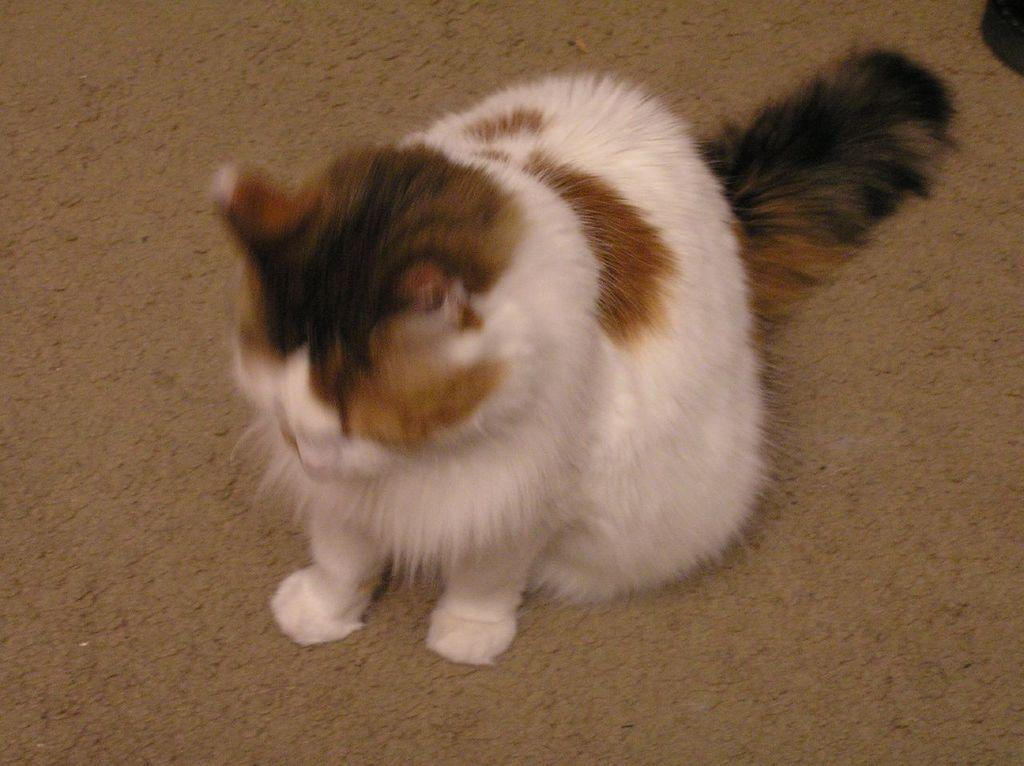What type of animal is in the image? There is a cat in the image. Where is the cat located in the image? The cat is on the ground. What can be seen in the top right corner of the image? There is an object in the top right corner of the image. What type of harmony is being played by the band in the image? There is no band present in the image, so it is not possible to determine what type of harmony might be played. 